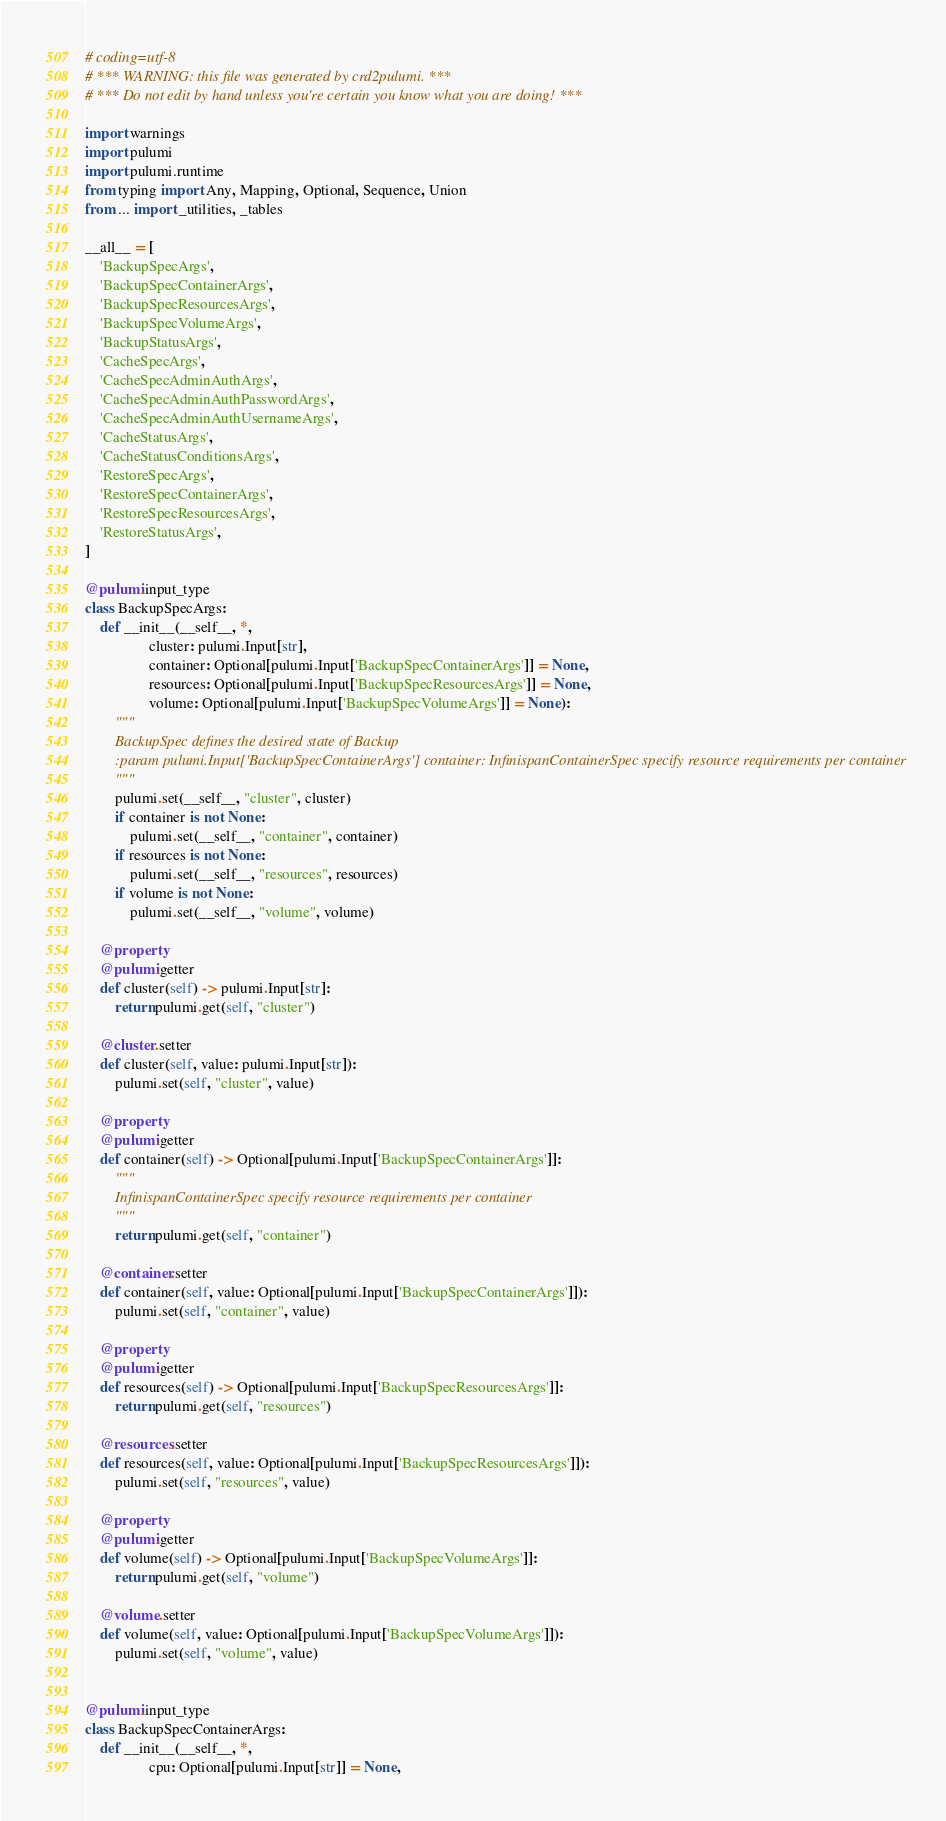<code> <loc_0><loc_0><loc_500><loc_500><_Python_># coding=utf-8
# *** WARNING: this file was generated by crd2pulumi. ***
# *** Do not edit by hand unless you're certain you know what you are doing! ***

import warnings
import pulumi
import pulumi.runtime
from typing import Any, Mapping, Optional, Sequence, Union
from ... import _utilities, _tables

__all__ = [
    'BackupSpecArgs',
    'BackupSpecContainerArgs',
    'BackupSpecResourcesArgs',
    'BackupSpecVolumeArgs',
    'BackupStatusArgs',
    'CacheSpecArgs',
    'CacheSpecAdminAuthArgs',
    'CacheSpecAdminAuthPasswordArgs',
    'CacheSpecAdminAuthUsernameArgs',
    'CacheStatusArgs',
    'CacheStatusConditionsArgs',
    'RestoreSpecArgs',
    'RestoreSpecContainerArgs',
    'RestoreSpecResourcesArgs',
    'RestoreStatusArgs',
]

@pulumi.input_type
class BackupSpecArgs:
    def __init__(__self__, *,
                 cluster: pulumi.Input[str],
                 container: Optional[pulumi.Input['BackupSpecContainerArgs']] = None,
                 resources: Optional[pulumi.Input['BackupSpecResourcesArgs']] = None,
                 volume: Optional[pulumi.Input['BackupSpecVolumeArgs']] = None):
        """
        BackupSpec defines the desired state of Backup
        :param pulumi.Input['BackupSpecContainerArgs'] container: InfinispanContainerSpec specify resource requirements per container
        """
        pulumi.set(__self__, "cluster", cluster)
        if container is not None:
            pulumi.set(__self__, "container", container)
        if resources is not None:
            pulumi.set(__self__, "resources", resources)
        if volume is not None:
            pulumi.set(__self__, "volume", volume)

    @property
    @pulumi.getter
    def cluster(self) -> pulumi.Input[str]:
        return pulumi.get(self, "cluster")

    @cluster.setter
    def cluster(self, value: pulumi.Input[str]):
        pulumi.set(self, "cluster", value)

    @property
    @pulumi.getter
    def container(self) -> Optional[pulumi.Input['BackupSpecContainerArgs']]:
        """
        InfinispanContainerSpec specify resource requirements per container
        """
        return pulumi.get(self, "container")

    @container.setter
    def container(self, value: Optional[pulumi.Input['BackupSpecContainerArgs']]):
        pulumi.set(self, "container", value)

    @property
    @pulumi.getter
    def resources(self) -> Optional[pulumi.Input['BackupSpecResourcesArgs']]:
        return pulumi.get(self, "resources")

    @resources.setter
    def resources(self, value: Optional[pulumi.Input['BackupSpecResourcesArgs']]):
        pulumi.set(self, "resources", value)

    @property
    @pulumi.getter
    def volume(self) -> Optional[pulumi.Input['BackupSpecVolumeArgs']]:
        return pulumi.get(self, "volume")

    @volume.setter
    def volume(self, value: Optional[pulumi.Input['BackupSpecVolumeArgs']]):
        pulumi.set(self, "volume", value)


@pulumi.input_type
class BackupSpecContainerArgs:
    def __init__(__self__, *,
                 cpu: Optional[pulumi.Input[str]] = None,</code> 